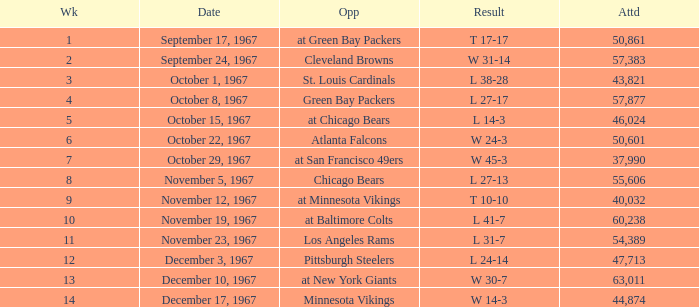How many weeks have a Result of t 10-10? 1.0. 